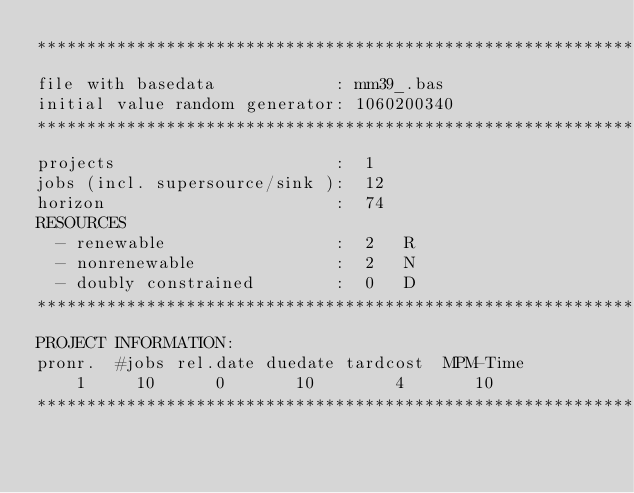<code> <loc_0><loc_0><loc_500><loc_500><_ObjectiveC_>************************************************************************
file with basedata            : mm39_.bas
initial value random generator: 1060200340
************************************************************************
projects                      :  1
jobs (incl. supersource/sink ):  12
horizon                       :  74
RESOURCES
  - renewable                 :  2   R
  - nonrenewable              :  2   N
  - doubly constrained        :  0   D
************************************************************************
PROJECT INFORMATION:
pronr.  #jobs rel.date duedate tardcost  MPM-Time
    1     10      0       10        4       10
************************************************************************</code> 